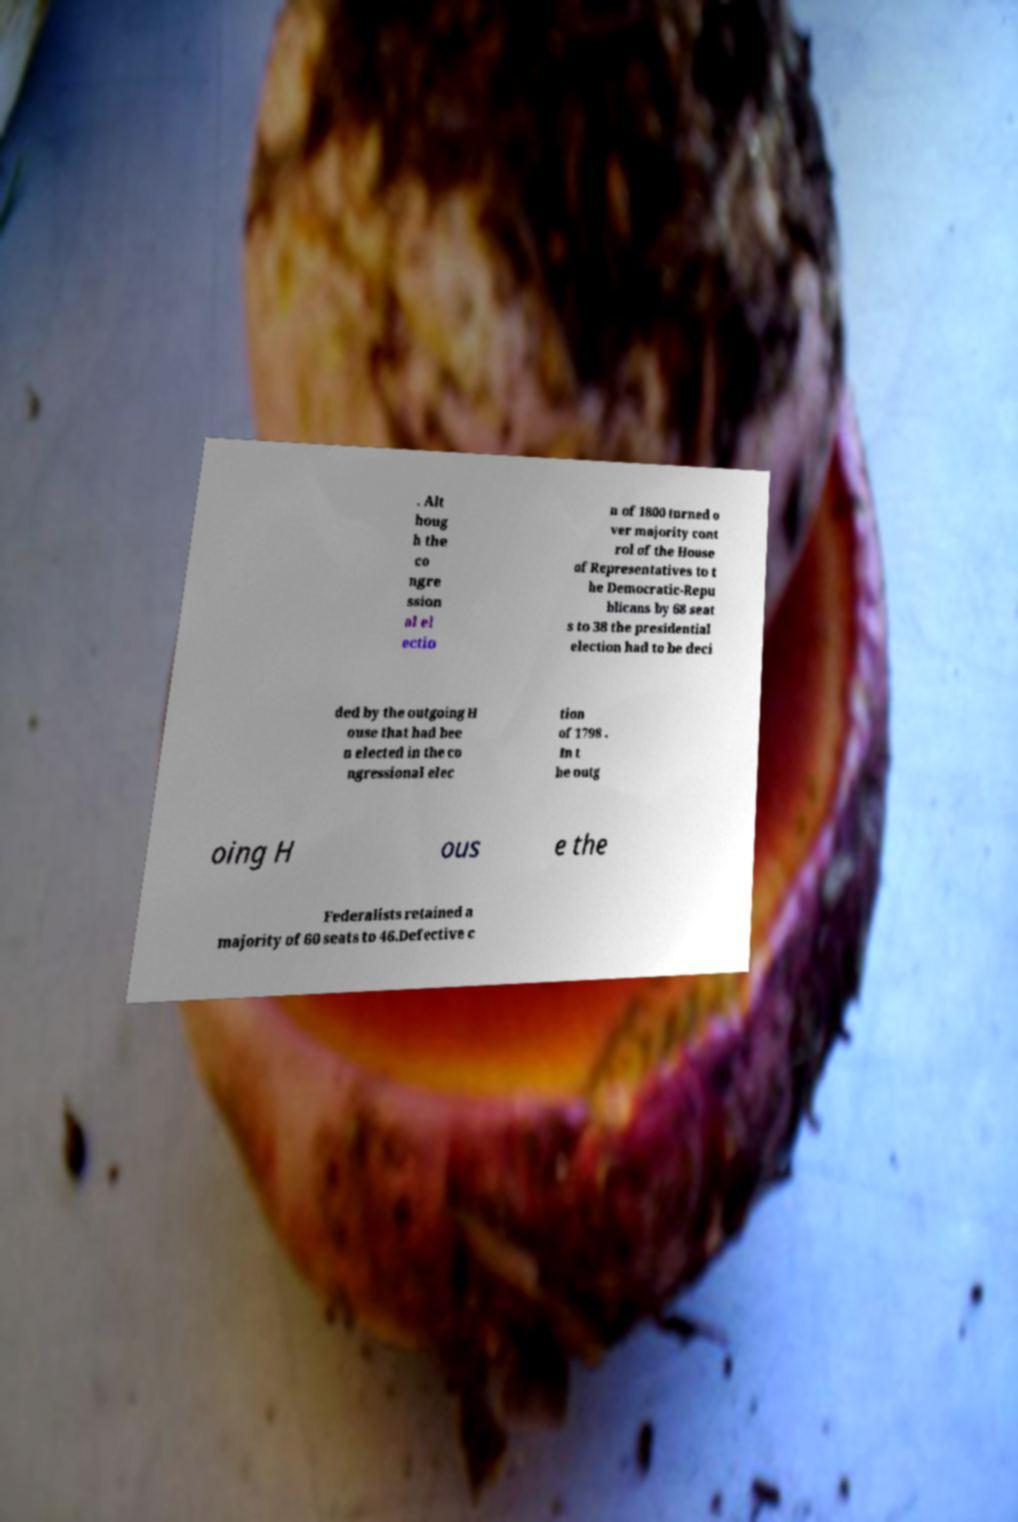Please read and relay the text visible in this image. What does it say? . Alt houg h the co ngre ssion al el ectio n of 1800 turned o ver majority cont rol of the House of Representatives to t he Democratic-Repu blicans by 68 seat s to 38 the presidential election had to be deci ded by the outgoing H ouse that had bee n elected in the co ngressional elec tion of 1798 . In t he outg oing H ous e the Federalists retained a majority of 60 seats to 46.Defective c 